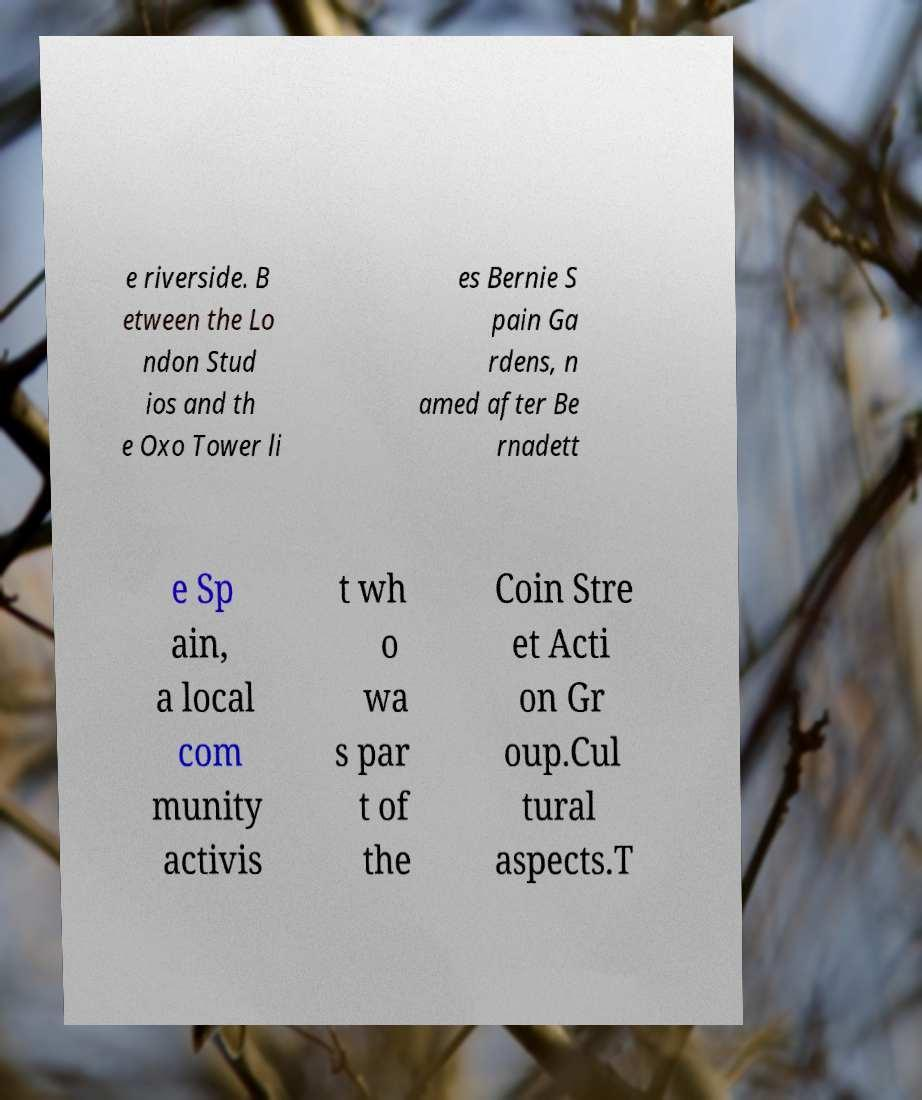Please identify and transcribe the text found in this image. e riverside. B etween the Lo ndon Stud ios and th e Oxo Tower li es Bernie S pain Ga rdens, n amed after Be rnadett e Sp ain, a local com munity activis t wh o wa s par t of the Coin Stre et Acti on Gr oup.Cul tural aspects.T 